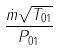<formula> <loc_0><loc_0><loc_500><loc_500>\frac { \dot { m } \sqrt { T _ { 0 1 } } } { P _ { 0 1 } }</formula> 